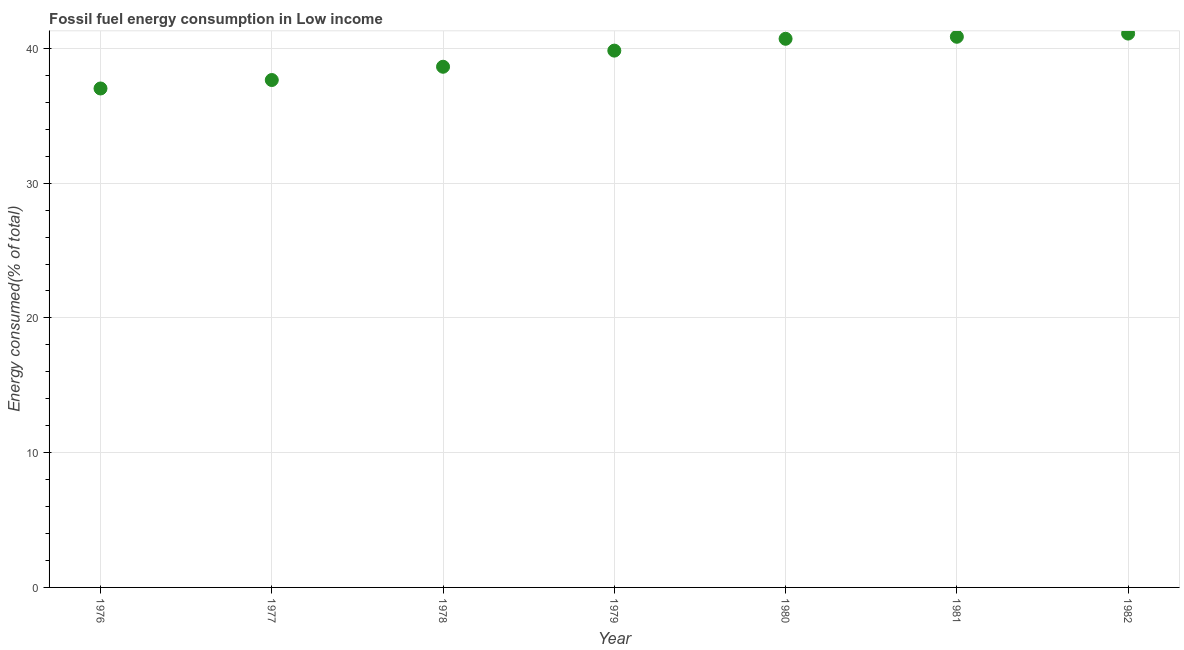What is the fossil fuel energy consumption in 1976?
Offer a very short reply. 37.02. Across all years, what is the maximum fossil fuel energy consumption?
Your answer should be very brief. 41.1. Across all years, what is the minimum fossil fuel energy consumption?
Your answer should be compact. 37.02. In which year was the fossil fuel energy consumption minimum?
Your answer should be very brief. 1976. What is the sum of the fossil fuel energy consumption?
Your response must be concise. 275.82. What is the difference between the fossil fuel energy consumption in 1980 and 1981?
Ensure brevity in your answer.  -0.15. What is the average fossil fuel energy consumption per year?
Your answer should be very brief. 39.4. What is the median fossil fuel energy consumption?
Offer a very short reply. 39.83. In how many years, is the fossil fuel energy consumption greater than 16 %?
Your response must be concise. 7. Do a majority of the years between 1978 and 1976 (inclusive) have fossil fuel energy consumption greater than 2 %?
Offer a terse response. No. What is the ratio of the fossil fuel energy consumption in 1978 to that in 1979?
Offer a terse response. 0.97. Is the difference between the fossil fuel energy consumption in 1977 and 1981 greater than the difference between any two years?
Provide a short and direct response. No. What is the difference between the highest and the second highest fossil fuel energy consumption?
Offer a terse response. 0.24. What is the difference between the highest and the lowest fossil fuel energy consumption?
Keep it short and to the point. 4.07. In how many years, is the fossil fuel energy consumption greater than the average fossil fuel energy consumption taken over all years?
Make the answer very short. 4. Does the fossil fuel energy consumption monotonically increase over the years?
Make the answer very short. Yes. How many dotlines are there?
Make the answer very short. 1. Does the graph contain any zero values?
Your answer should be very brief. No. What is the title of the graph?
Offer a very short reply. Fossil fuel energy consumption in Low income. What is the label or title of the X-axis?
Your response must be concise. Year. What is the label or title of the Y-axis?
Provide a succinct answer. Energy consumed(% of total). What is the Energy consumed(% of total) in 1976?
Provide a short and direct response. 37.02. What is the Energy consumed(% of total) in 1977?
Ensure brevity in your answer.  37.65. What is the Energy consumed(% of total) in 1978?
Keep it short and to the point. 38.64. What is the Energy consumed(% of total) in 1979?
Offer a terse response. 39.83. What is the Energy consumed(% of total) in 1980?
Your response must be concise. 40.71. What is the Energy consumed(% of total) in 1981?
Offer a very short reply. 40.86. What is the Energy consumed(% of total) in 1982?
Make the answer very short. 41.1. What is the difference between the Energy consumed(% of total) in 1976 and 1977?
Your response must be concise. -0.63. What is the difference between the Energy consumed(% of total) in 1976 and 1978?
Provide a succinct answer. -1.61. What is the difference between the Energy consumed(% of total) in 1976 and 1979?
Your answer should be compact. -2.81. What is the difference between the Energy consumed(% of total) in 1976 and 1980?
Offer a terse response. -3.69. What is the difference between the Energy consumed(% of total) in 1976 and 1981?
Make the answer very short. -3.84. What is the difference between the Energy consumed(% of total) in 1976 and 1982?
Your answer should be very brief. -4.07. What is the difference between the Energy consumed(% of total) in 1977 and 1978?
Give a very brief answer. -0.98. What is the difference between the Energy consumed(% of total) in 1977 and 1979?
Make the answer very short. -2.18. What is the difference between the Energy consumed(% of total) in 1977 and 1980?
Ensure brevity in your answer.  -3.06. What is the difference between the Energy consumed(% of total) in 1977 and 1981?
Your response must be concise. -3.21. What is the difference between the Energy consumed(% of total) in 1977 and 1982?
Offer a very short reply. -3.45. What is the difference between the Energy consumed(% of total) in 1978 and 1979?
Provide a short and direct response. -1.2. What is the difference between the Energy consumed(% of total) in 1978 and 1980?
Provide a succinct answer. -2.08. What is the difference between the Energy consumed(% of total) in 1978 and 1981?
Your response must be concise. -2.23. What is the difference between the Energy consumed(% of total) in 1978 and 1982?
Give a very brief answer. -2.46. What is the difference between the Energy consumed(% of total) in 1979 and 1980?
Your answer should be very brief. -0.88. What is the difference between the Energy consumed(% of total) in 1979 and 1981?
Keep it short and to the point. -1.03. What is the difference between the Energy consumed(% of total) in 1979 and 1982?
Your answer should be compact. -1.27. What is the difference between the Energy consumed(% of total) in 1980 and 1982?
Give a very brief answer. -0.39. What is the difference between the Energy consumed(% of total) in 1981 and 1982?
Provide a succinct answer. -0.24. What is the ratio of the Energy consumed(% of total) in 1976 to that in 1978?
Your answer should be very brief. 0.96. What is the ratio of the Energy consumed(% of total) in 1976 to that in 1979?
Provide a succinct answer. 0.93. What is the ratio of the Energy consumed(% of total) in 1976 to that in 1980?
Make the answer very short. 0.91. What is the ratio of the Energy consumed(% of total) in 1976 to that in 1981?
Keep it short and to the point. 0.91. What is the ratio of the Energy consumed(% of total) in 1976 to that in 1982?
Ensure brevity in your answer.  0.9. What is the ratio of the Energy consumed(% of total) in 1977 to that in 1978?
Make the answer very short. 0.97. What is the ratio of the Energy consumed(% of total) in 1977 to that in 1979?
Provide a short and direct response. 0.94. What is the ratio of the Energy consumed(% of total) in 1977 to that in 1980?
Offer a very short reply. 0.93. What is the ratio of the Energy consumed(% of total) in 1977 to that in 1981?
Provide a succinct answer. 0.92. What is the ratio of the Energy consumed(% of total) in 1977 to that in 1982?
Give a very brief answer. 0.92. What is the ratio of the Energy consumed(% of total) in 1978 to that in 1979?
Provide a short and direct response. 0.97. What is the ratio of the Energy consumed(% of total) in 1978 to that in 1980?
Provide a short and direct response. 0.95. What is the ratio of the Energy consumed(% of total) in 1978 to that in 1981?
Make the answer very short. 0.95. What is the ratio of the Energy consumed(% of total) in 1978 to that in 1982?
Give a very brief answer. 0.94. What is the ratio of the Energy consumed(% of total) in 1979 to that in 1981?
Ensure brevity in your answer.  0.97. What is the ratio of the Energy consumed(% of total) in 1980 to that in 1982?
Keep it short and to the point. 0.99. 